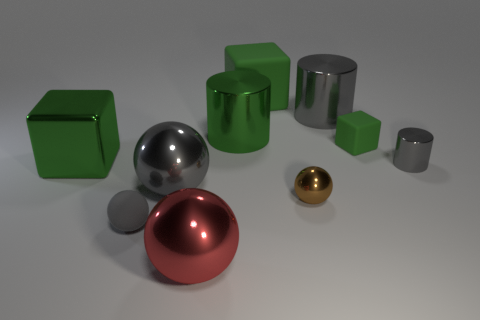Do the small metallic thing in front of the tiny gray cylinder and the rubber sphere have the same color?
Your response must be concise. No. What number of things are either gray metal balls or objects behind the small gray metal object?
Keep it short and to the point. 6. There is a gray object that is both to the right of the tiny brown sphere and in front of the large green shiny cylinder; what is its material?
Make the answer very short. Metal. There is a large block that is behind the small green cube; what material is it?
Your answer should be compact. Rubber. There is a small object that is the same material as the tiny gray cylinder; what is its color?
Give a very brief answer. Brown. There is a big red metallic object; is it the same shape as the small gray object to the right of the small green thing?
Make the answer very short. No. Are there any tiny brown balls in front of the large gray metallic sphere?
Keep it short and to the point. Yes. What material is the cylinder that is the same color as the small cube?
Give a very brief answer. Metal. Does the green cylinder have the same size as the metallic object that is in front of the gray rubber ball?
Provide a succinct answer. Yes. Is there a big metallic object that has the same color as the tiny matte block?
Offer a very short reply. Yes. 